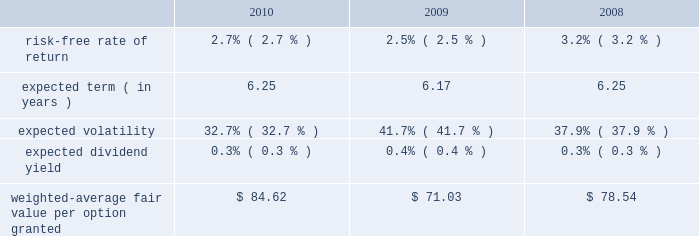Mastercard incorporated notes to consolidated financial statements 2014continued in september 2010 , the company 2019s board of directors authorized a plan for the company to repurchase up to $ 1 billion of its class a common stock in open market transactions .
The company did not repurchase any shares under this plan during 2010 .
As of february 16 , 2011 , the company had completed the repurchase of approximately 0.3 million shares of its class a common stock at a cost of approximately $ 75 million .
Note 18 .
Share based payment and other benefits in may 2006 , the company implemented the mastercard incorporated 2006 long-term incentive plan , which was amended and restated as of october 13 , 2008 ( the 201cltip 201d ) .
The ltip is a shareholder-approved omnibus plan that permits the grant of various types of equity awards to employees .
The company has granted restricted stock units ( 201crsus 201d ) , non-qualified stock options ( 201coptions 201d ) and performance stock units ( 201cpsus 201d ) under the ltip .
The rsus generally vest after three to four years .
The options , which expire ten years from the date of grant , generally vest ratably over four years from the date of grant .
The psus generally vest after three years .
Additionally , the company made a one-time grant to all non-executive management employees upon the ipo for a total of approximately 440 thousand rsus ( the 201cfounders 2019 grant 201d ) .
The founders 2019 grant rsus vested three years from the date of grant .
The company uses the straight-line method of attribution for expensing equity awards .
Compensation expense is recorded net of estimated forfeitures .
Estimates are adjusted as appropriate .
Upon termination of employment , excluding retirement , all of a participant 2019s unvested awards are forfeited .
However , when a participant terminates employment due to retirement , the participant generally retains all of their awards without providing additional service to the company .
Eligible retirement is dependent upon age and years of service , as follows : age 55 with ten years of service , age 60 with five years of service and age 65 with two years of service .
Compensation expense is recognized over the shorter of the vesting periods stated in the ltip , or the date the individual becomes eligible to retire .
There are 11550000 shares of class a common stock reserved for equity awards under the ltip .
Although the ltip permits the issuance of shares of class b common stock , no such shares have been reserved for issuance .
Shares issued as a result of option exercises and the conversions of rsus and psus are expected to be funded primarily with the issuance of new shares of class a common stock .
Stock options the fair value of each option is estimated on the date of grant using a black-scholes option pricing model .
The table presents the weighted-average assumptions used in the valuation and the resulting weighted- average fair value per option granted for the years ended december 31: .
The risk-free rate of return was based on the u.s .
Treasury yield curve in effect on the date of grant .
The company utilizes the simplified method for calculating the expected term of the option based on the vesting terms and the contractual life of the option .
The expected volatility for options granted during 2010 and 2009 was based on the average of the implied volatility of mastercard and a blend of the historical volatility of mastercard and the historical volatility of a group of companies that management believes is generally comparable to .
What is the average expected dividend yield during 2008-2010? 
Rationale: it is the sum of all expected dividends yield divided by three .
Computations: table_average(expected dividend yield, none)
Answer: 0.00333. 